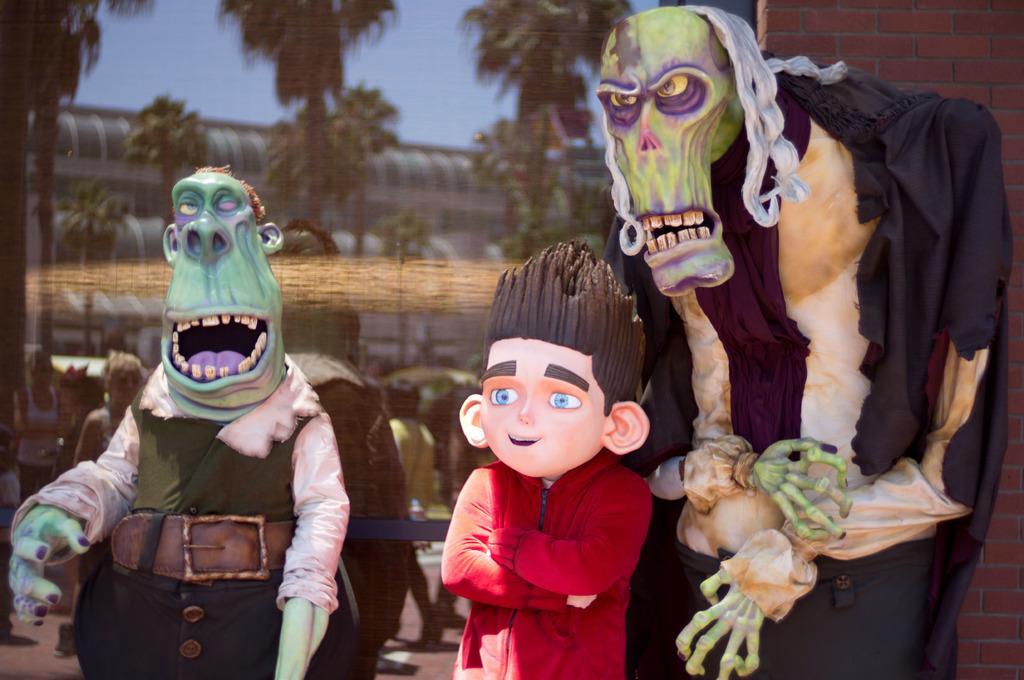Describe this image in one or two sentences. In this image we can see the statues. And this is an animated image. And in the background, we can see a poster which includes some people and trees. And we can see the brick wall. 